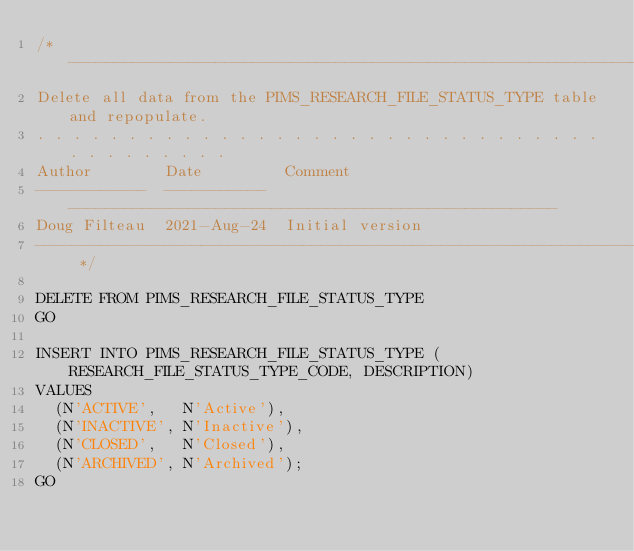Convert code to text. <code><loc_0><loc_0><loc_500><loc_500><_SQL_>/* -----------------------------------------------------------------------------
Delete all data from the PIMS_RESEARCH_FILE_STATUS_TYPE table and repopulate.
. . . . . . . . . . . . . . . . . . . . . . . . . . . . . . . . . . . . . . . .
Author        Date         Comment
------------  -----------  -----------------------------------------------------
Doug Filteau  2021-Aug-24  Initial version
----------------------------------------------------------------------------- */

DELETE FROM PIMS_RESEARCH_FILE_STATUS_TYPE
GO

INSERT INTO PIMS_RESEARCH_FILE_STATUS_TYPE (RESEARCH_FILE_STATUS_TYPE_CODE, DESCRIPTION)
VALUES
  (N'ACTIVE',   N'Active'),
  (N'INACTIVE', N'Inactive'),
  (N'CLOSED',   N'Closed'),
  (N'ARCHIVED', N'Archived');
GO
</code> 